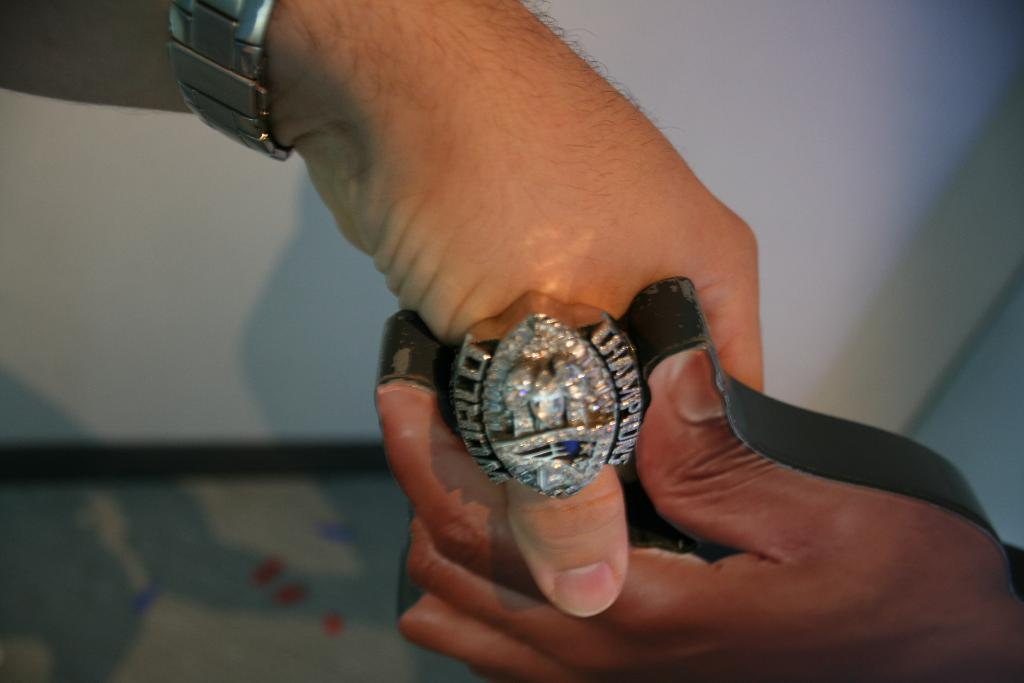<image>
Render a clear and concise summary of the photo. A piece of Jewelry covered in diamonds with Champions written on it. 